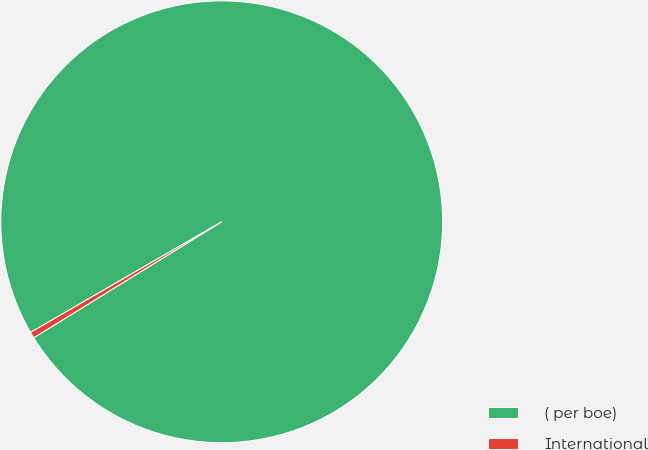Convert chart. <chart><loc_0><loc_0><loc_500><loc_500><pie_chart><fcel>( per boe)<fcel>International<nl><fcel>99.55%<fcel>0.45%<nl></chart> 